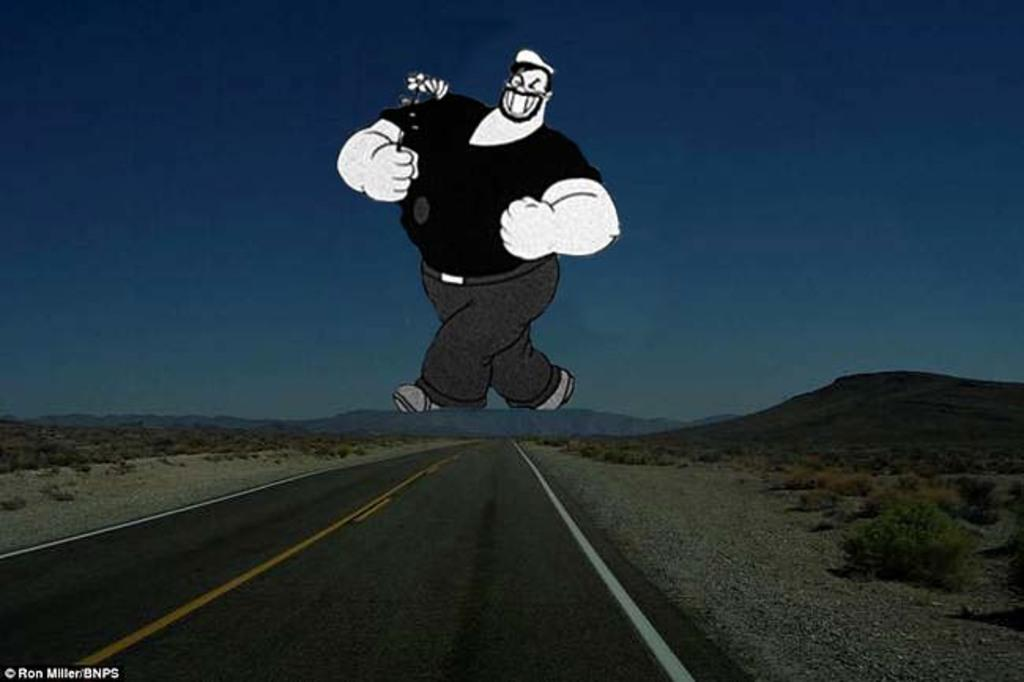What is the main feature of the image? There is a road in the image. What can be seen in the distance behind the road? There is a mountain and a cartoon in the background of the image. What is visible in the sky in the image? The sky is visible in the background of the image. What type of brass instrument is being played by the partner in the image? There is no brass instrument or partner present in the image. 